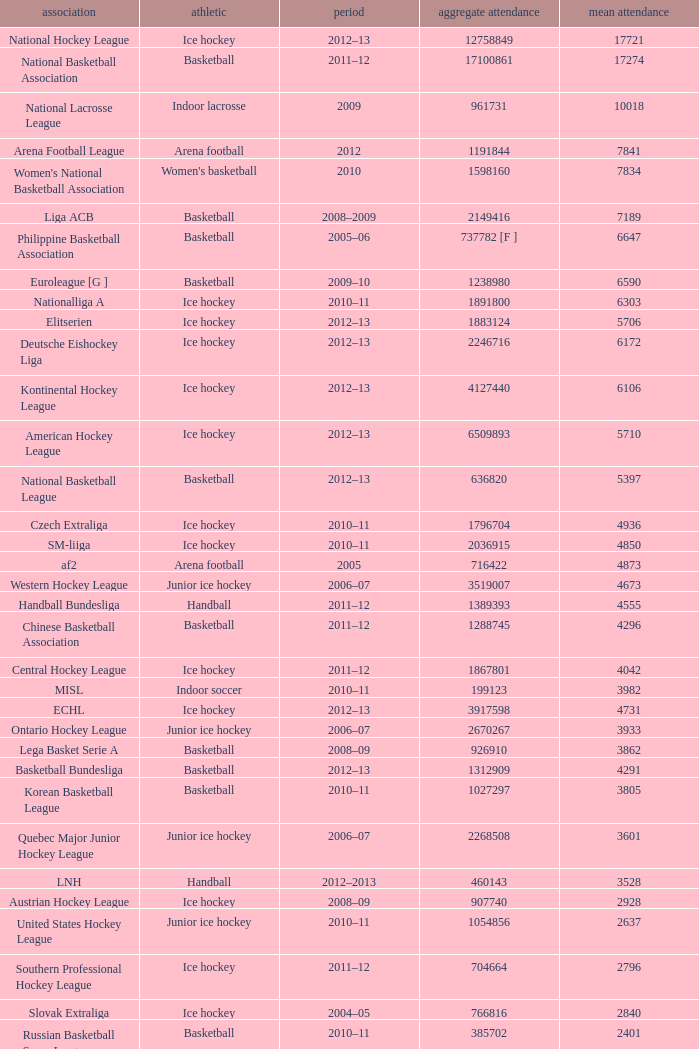What is the mean attendance for a league that has a total attendance of 2,268,508? 3601.0. 